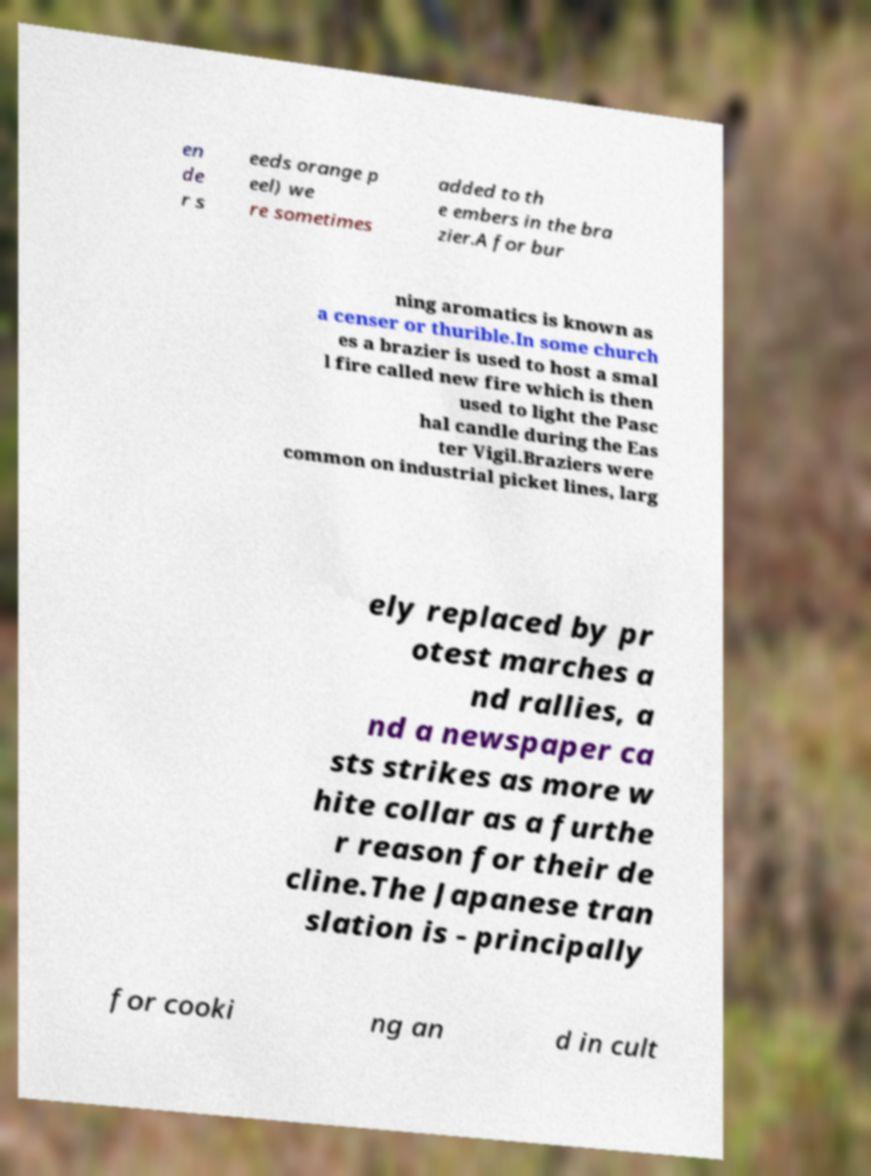Could you extract and type out the text from this image? en de r s eeds orange p eel) we re sometimes added to th e embers in the bra zier.A for bur ning aromatics is known as a censer or thurible.In some church es a brazier is used to host a smal l fire called new fire which is then used to light the Pasc hal candle during the Eas ter Vigil.Braziers were common on industrial picket lines, larg ely replaced by pr otest marches a nd rallies, a nd a newspaper ca sts strikes as more w hite collar as a furthe r reason for their de cline.The Japanese tran slation is - principally for cooki ng an d in cult 